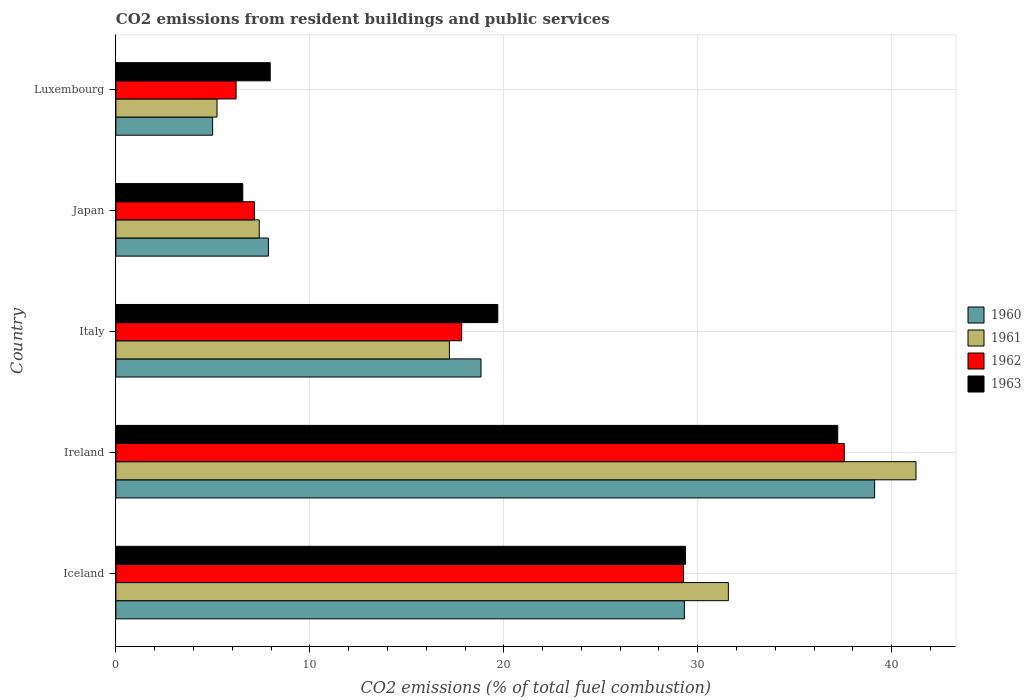How many groups of bars are there?
Offer a terse response. 5. Are the number of bars per tick equal to the number of legend labels?
Ensure brevity in your answer.  Yes. What is the label of the 3rd group of bars from the top?
Give a very brief answer. Italy. In how many cases, is the number of bars for a given country not equal to the number of legend labels?
Offer a very short reply. 0. What is the total CO2 emitted in 1960 in Iceland?
Your response must be concise. 29.31. Across all countries, what is the maximum total CO2 emitted in 1960?
Provide a short and direct response. 39.12. Across all countries, what is the minimum total CO2 emitted in 1963?
Make the answer very short. 6.54. In which country was the total CO2 emitted in 1963 maximum?
Provide a succinct answer. Ireland. In which country was the total CO2 emitted in 1961 minimum?
Give a very brief answer. Luxembourg. What is the total total CO2 emitted in 1960 in the graph?
Offer a very short reply. 100.11. What is the difference between the total CO2 emitted in 1963 in Iceland and that in Ireland?
Provide a short and direct response. -7.85. What is the difference between the total CO2 emitted in 1960 in Japan and the total CO2 emitted in 1962 in Italy?
Provide a succinct answer. -9.97. What is the average total CO2 emitted in 1960 per country?
Give a very brief answer. 20.02. What is the difference between the total CO2 emitted in 1960 and total CO2 emitted in 1961 in Ireland?
Provide a short and direct response. -2.13. In how many countries, is the total CO2 emitted in 1962 greater than 18 ?
Ensure brevity in your answer.  2. What is the ratio of the total CO2 emitted in 1961 in Ireland to that in Japan?
Your answer should be very brief. 5.58. Is the total CO2 emitted in 1963 in Iceland less than that in Luxembourg?
Your answer should be very brief. No. What is the difference between the highest and the second highest total CO2 emitted in 1962?
Your answer should be very brief. 8.29. What is the difference between the highest and the lowest total CO2 emitted in 1961?
Ensure brevity in your answer.  36.04. What does the 3rd bar from the top in Japan represents?
Ensure brevity in your answer.  1961. Is it the case that in every country, the sum of the total CO2 emitted in 1962 and total CO2 emitted in 1961 is greater than the total CO2 emitted in 1960?
Ensure brevity in your answer.  Yes. Are all the bars in the graph horizontal?
Provide a succinct answer. Yes. How many countries are there in the graph?
Offer a very short reply. 5. What is the difference between two consecutive major ticks on the X-axis?
Offer a terse response. 10. Does the graph contain any zero values?
Your response must be concise. No. Does the graph contain grids?
Your response must be concise. Yes. How many legend labels are there?
Offer a very short reply. 4. What is the title of the graph?
Your response must be concise. CO2 emissions from resident buildings and public services. Does "1973" appear as one of the legend labels in the graph?
Offer a very short reply. No. What is the label or title of the X-axis?
Give a very brief answer. CO2 emissions (% of total fuel combustion). What is the label or title of the Y-axis?
Give a very brief answer. Country. What is the CO2 emissions (% of total fuel combustion) of 1960 in Iceland?
Keep it short and to the point. 29.31. What is the CO2 emissions (% of total fuel combustion) in 1961 in Iceland?
Your answer should be compact. 31.58. What is the CO2 emissions (% of total fuel combustion) in 1962 in Iceland?
Your answer should be very brief. 29.27. What is the CO2 emissions (% of total fuel combustion) of 1963 in Iceland?
Ensure brevity in your answer.  29.37. What is the CO2 emissions (% of total fuel combustion) in 1960 in Ireland?
Ensure brevity in your answer.  39.12. What is the CO2 emissions (% of total fuel combustion) of 1961 in Ireland?
Your answer should be very brief. 41.25. What is the CO2 emissions (% of total fuel combustion) in 1962 in Ireland?
Make the answer very short. 37.55. What is the CO2 emissions (% of total fuel combustion) of 1963 in Ireland?
Provide a short and direct response. 37.22. What is the CO2 emissions (% of total fuel combustion) in 1960 in Italy?
Your answer should be very brief. 18.83. What is the CO2 emissions (% of total fuel combustion) in 1961 in Italy?
Provide a succinct answer. 17.2. What is the CO2 emissions (% of total fuel combustion) in 1962 in Italy?
Give a very brief answer. 17.83. What is the CO2 emissions (% of total fuel combustion) of 1963 in Italy?
Your answer should be very brief. 19.69. What is the CO2 emissions (% of total fuel combustion) of 1960 in Japan?
Give a very brief answer. 7.86. What is the CO2 emissions (% of total fuel combustion) of 1961 in Japan?
Make the answer very short. 7.39. What is the CO2 emissions (% of total fuel combustion) of 1962 in Japan?
Offer a terse response. 7.14. What is the CO2 emissions (% of total fuel combustion) of 1963 in Japan?
Give a very brief answer. 6.54. What is the CO2 emissions (% of total fuel combustion) of 1960 in Luxembourg?
Make the answer very short. 4.99. What is the CO2 emissions (% of total fuel combustion) of 1961 in Luxembourg?
Provide a succinct answer. 5.21. What is the CO2 emissions (% of total fuel combustion) of 1962 in Luxembourg?
Ensure brevity in your answer.  6.2. What is the CO2 emissions (% of total fuel combustion) of 1963 in Luxembourg?
Keep it short and to the point. 7.96. Across all countries, what is the maximum CO2 emissions (% of total fuel combustion) in 1960?
Provide a short and direct response. 39.12. Across all countries, what is the maximum CO2 emissions (% of total fuel combustion) in 1961?
Ensure brevity in your answer.  41.25. Across all countries, what is the maximum CO2 emissions (% of total fuel combustion) in 1962?
Give a very brief answer. 37.55. Across all countries, what is the maximum CO2 emissions (% of total fuel combustion) of 1963?
Give a very brief answer. 37.22. Across all countries, what is the minimum CO2 emissions (% of total fuel combustion) in 1960?
Your response must be concise. 4.99. Across all countries, what is the minimum CO2 emissions (% of total fuel combustion) of 1961?
Ensure brevity in your answer.  5.21. Across all countries, what is the minimum CO2 emissions (% of total fuel combustion) in 1962?
Your answer should be compact. 6.2. Across all countries, what is the minimum CO2 emissions (% of total fuel combustion) in 1963?
Ensure brevity in your answer.  6.54. What is the total CO2 emissions (% of total fuel combustion) of 1960 in the graph?
Offer a very short reply. 100.11. What is the total CO2 emissions (% of total fuel combustion) of 1961 in the graph?
Ensure brevity in your answer.  102.63. What is the total CO2 emissions (% of total fuel combustion) in 1962 in the graph?
Your answer should be very brief. 97.99. What is the total CO2 emissions (% of total fuel combustion) of 1963 in the graph?
Make the answer very short. 100.78. What is the difference between the CO2 emissions (% of total fuel combustion) in 1960 in Iceland and that in Ireland?
Your response must be concise. -9.81. What is the difference between the CO2 emissions (% of total fuel combustion) in 1961 in Iceland and that in Ireland?
Keep it short and to the point. -9.67. What is the difference between the CO2 emissions (% of total fuel combustion) of 1962 in Iceland and that in Ireland?
Your answer should be very brief. -8.29. What is the difference between the CO2 emissions (% of total fuel combustion) in 1963 in Iceland and that in Ireland?
Your answer should be compact. -7.85. What is the difference between the CO2 emissions (% of total fuel combustion) of 1960 in Iceland and that in Italy?
Offer a very short reply. 10.48. What is the difference between the CO2 emissions (% of total fuel combustion) in 1961 in Iceland and that in Italy?
Make the answer very short. 14.38. What is the difference between the CO2 emissions (% of total fuel combustion) in 1962 in Iceland and that in Italy?
Your response must be concise. 11.44. What is the difference between the CO2 emissions (% of total fuel combustion) of 1963 in Iceland and that in Italy?
Make the answer very short. 9.67. What is the difference between the CO2 emissions (% of total fuel combustion) of 1960 in Iceland and that in Japan?
Your answer should be very brief. 21.45. What is the difference between the CO2 emissions (% of total fuel combustion) of 1961 in Iceland and that in Japan?
Your answer should be compact. 24.19. What is the difference between the CO2 emissions (% of total fuel combustion) in 1962 in Iceland and that in Japan?
Offer a very short reply. 22.13. What is the difference between the CO2 emissions (% of total fuel combustion) of 1963 in Iceland and that in Japan?
Offer a terse response. 22.82. What is the difference between the CO2 emissions (% of total fuel combustion) in 1960 in Iceland and that in Luxembourg?
Ensure brevity in your answer.  24.32. What is the difference between the CO2 emissions (% of total fuel combustion) in 1961 in Iceland and that in Luxembourg?
Make the answer very short. 26.36. What is the difference between the CO2 emissions (% of total fuel combustion) in 1962 in Iceland and that in Luxembourg?
Offer a terse response. 23.07. What is the difference between the CO2 emissions (% of total fuel combustion) of 1963 in Iceland and that in Luxembourg?
Ensure brevity in your answer.  21.41. What is the difference between the CO2 emissions (% of total fuel combustion) of 1960 in Ireland and that in Italy?
Give a very brief answer. 20.29. What is the difference between the CO2 emissions (% of total fuel combustion) in 1961 in Ireland and that in Italy?
Give a very brief answer. 24.06. What is the difference between the CO2 emissions (% of total fuel combustion) of 1962 in Ireland and that in Italy?
Provide a short and direct response. 19.73. What is the difference between the CO2 emissions (% of total fuel combustion) in 1963 in Ireland and that in Italy?
Your answer should be compact. 17.53. What is the difference between the CO2 emissions (% of total fuel combustion) of 1960 in Ireland and that in Japan?
Ensure brevity in your answer.  31.26. What is the difference between the CO2 emissions (% of total fuel combustion) in 1961 in Ireland and that in Japan?
Keep it short and to the point. 33.86. What is the difference between the CO2 emissions (% of total fuel combustion) in 1962 in Ireland and that in Japan?
Your response must be concise. 30.41. What is the difference between the CO2 emissions (% of total fuel combustion) of 1963 in Ireland and that in Japan?
Keep it short and to the point. 30.68. What is the difference between the CO2 emissions (% of total fuel combustion) of 1960 in Ireland and that in Luxembourg?
Your answer should be very brief. 34.13. What is the difference between the CO2 emissions (% of total fuel combustion) in 1961 in Ireland and that in Luxembourg?
Your response must be concise. 36.04. What is the difference between the CO2 emissions (% of total fuel combustion) in 1962 in Ireland and that in Luxembourg?
Your answer should be very brief. 31.36. What is the difference between the CO2 emissions (% of total fuel combustion) of 1963 in Ireland and that in Luxembourg?
Your answer should be compact. 29.26. What is the difference between the CO2 emissions (% of total fuel combustion) of 1960 in Italy and that in Japan?
Keep it short and to the point. 10.96. What is the difference between the CO2 emissions (% of total fuel combustion) of 1961 in Italy and that in Japan?
Provide a short and direct response. 9.81. What is the difference between the CO2 emissions (% of total fuel combustion) of 1962 in Italy and that in Japan?
Your answer should be very brief. 10.69. What is the difference between the CO2 emissions (% of total fuel combustion) of 1963 in Italy and that in Japan?
Your answer should be compact. 13.15. What is the difference between the CO2 emissions (% of total fuel combustion) of 1960 in Italy and that in Luxembourg?
Ensure brevity in your answer.  13.84. What is the difference between the CO2 emissions (% of total fuel combustion) of 1961 in Italy and that in Luxembourg?
Offer a terse response. 11.98. What is the difference between the CO2 emissions (% of total fuel combustion) of 1962 in Italy and that in Luxembourg?
Keep it short and to the point. 11.63. What is the difference between the CO2 emissions (% of total fuel combustion) in 1963 in Italy and that in Luxembourg?
Offer a very short reply. 11.73. What is the difference between the CO2 emissions (% of total fuel combustion) of 1960 in Japan and that in Luxembourg?
Your answer should be compact. 2.87. What is the difference between the CO2 emissions (% of total fuel combustion) of 1961 in Japan and that in Luxembourg?
Keep it short and to the point. 2.18. What is the difference between the CO2 emissions (% of total fuel combustion) of 1962 in Japan and that in Luxembourg?
Provide a short and direct response. 0.94. What is the difference between the CO2 emissions (% of total fuel combustion) of 1963 in Japan and that in Luxembourg?
Provide a succinct answer. -1.41. What is the difference between the CO2 emissions (% of total fuel combustion) of 1960 in Iceland and the CO2 emissions (% of total fuel combustion) of 1961 in Ireland?
Ensure brevity in your answer.  -11.94. What is the difference between the CO2 emissions (% of total fuel combustion) in 1960 in Iceland and the CO2 emissions (% of total fuel combustion) in 1962 in Ireland?
Offer a very short reply. -8.24. What is the difference between the CO2 emissions (% of total fuel combustion) in 1960 in Iceland and the CO2 emissions (% of total fuel combustion) in 1963 in Ireland?
Your response must be concise. -7.91. What is the difference between the CO2 emissions (% of total fuel combustion) of 1961 in Iceland and the CO2 emissions (% of total fuel combustion) of 1962 in Ireland?
Offer a very short reply. -5.98. What is the difference between the CO2 emissions (% of total fuel combustion) of 1961 in Iceland and the CO2 emissions (% of total fuel combustion) of 1963 in Ireland?
Your answer should be compact. -5.64. What is the difference between the CO2 emissions (% of total fuel combustion) of 1962 in Iceland and the CO2 emissions (% of total fuel combustion) of 1963 in Ireland?
Provide a short and direct response. -7.95. What is the difference between the CO2 emissions (% of total fuel combustion) in 1960 in Iceland and the CO2 emissions (% of total fuel combustion) in 1961 in Italy?
Provide a short and direct response. 12.11. What is the difference between the CO2 emissions (% of total fuel combustion) in 1960 in Iceland and the CO2 emissions (% of total fuel combustion) in 1962 in Italy?
Offer a terse response. 11.48. What is the difference between the CO2 emissions (% of total fuel combustion) of 1960 in Iceland and the CO2 emissions (% of total fuel combustion) of 1963 in Italy?
Your answer should be very brief. 9.62. What is the difference between the CO2 emissions (% of total fuel combustion) in 1961 in Iceland and the CO2 emissions (% of total fuel combustion) in 1962 in Italy?
Offer a terse response. 13.75. What is the difference between the CO2 emissions (% of total fuel combustion) of 1961 in Iceland and the CO2 emissions (% of total fuel combustion) of 1963 in Italy?
Provide a short and direct response. 11.89. What is the difference between the CO2 emissions (% of total fuel combustion) of 1962 in Iceland and the CO2 emissions (% of total fuel combustion) of 1963 in Italy?
Provide a succinct answer. 9.58. What is the difference between the CO2 emissions (% of total fuel combustion) of 1960 in Iceland and the CO2 emissions (% of total fuel combustion) of 1961 in Japan?
Provide a succinct answer. 21.92. What is the difference between the CO2 emissions (% of total fuel combustion) of 1960 in Iceland and the CO2 emissions (% of total fuel combustion) of 1962 in Japan?
Provide a short and direct response. 22.17. What is the difference between the CO2 emissions (% of total fuel combustion) in 1960 in Iceland and the CO2 emissions (% of total fuel combustion) in 1963 in Japan?
Provide a short and direct response. 22.77. What is the difference between the CO2 emissions (% of total fuel combustion) in 1961 in Iceland and the CO2 emissions (% of total fuel combustion) in 1962 in Japan?
Your response must be concise. 24.44. What is the difference between the CO2 emissions (% of total fuel combustion) of 1961 in Iceland and the CO2 emissions (% of total fuel combustion) of 1963 in Japan?
Your answer should be compact. 25.04. What is the difference between the CO2 emissions (% of total fuel combustion) in 1962 in Iceland and the CO2 emissions (% of total fuel combustion) in 1963 in Japan?
Make the answer very short. 22.73. What is the difference between the CO2 emissions (% of total fuel combustion) in 1960 in Iceland and the CO2 emissions (% of total fuel combustion) in 1961 in Luxembourg?
Provide a succinct answer. 24.1. What is the difference between the CO2 emissions (% of total fuel combustion) in 1960 in Iceland and the CO2 emissions (% of total fuel combustion) in 1962 in Luxembourg?
Give a very brief answer. 23.11. What is the difference between the CO2 emissions (% of total fuel combustion) of 1960 in Iceland and the CO2 emissions (% of total fuel combustion) of 1963 in Luxembourg?
Ensure brevity in your answer.  21.35. What is the difference between the CO2 emissions (% of total fuel combustion) in 1961 in Iceland and the CO2 emissions (% of total fuel combustion) in 1962 in Luxembourg?
Give a very brief answer. 25.38. What is the difference between the CO2 emissions (% of total fuel combustion) of 1961 in Iceland and the CO2 emissions (% of total fuel combustion) of 1963 in Luxembourg?
Provide a short and direct response. 23.62. What is the difference between the CO2 emissions (% of total fuel combustion) of 1962 in Iceland and the CO2 emissions (% of total fuel combustion) of 1963 in Luxembourg?
Ensure brevity in your answer.  21.31. What is the difference between the CO2 emissions (% of total fuel combustion) in 1960 in Ireland and the CO2 emissions (% of total fuel combustion) in 1961 in Italy?
Offer a terse response. 21.92. What is the difference between the CO2 emissions (% of total fuel combustion) of 1960 in Ireland and the CO2 emissions (% of total fuel combustion) of 1962 in Italy?
Your answer should be compact. 21.29. What is the difference between the CO2 emissions (% of total fuel combustion) of 1960 in Ireland and the CO2 emissions (% of total fuel combustion) of 1963 in Italy?
Your answer should be very brief. 19.43. What is the difference between the CO2 emissions (% of total fuel combustion) of 1961 in Ireland and the CO2 emissions (% of total fuel combustion) of 1962 in Italy?
Your answer should be compact. 23.42. What is the difference between the CO2 emissions (% of total fuel combustion) of 1961 in Ireland and the CO2 emissions (% of total fuel combustion) of 1963 in Italy?
Your answer should be compact. 21.56. What is the difference between the CO2 emissions (% of total fuel combustion) in 1962 in Ireland and the CO2 emissions (% of total fuel combustion) in 1963 in Italy?
Your answer should be very brief. 17.86. What is the difference between the CO2 emissions (% of total fuel combustion) in 1960 in Ireland and the CO2 emissions (% of total fuel combustion) in 1961 in Japan?
Ensure brevity in your answer.  31.73. What is the difference between the CO2 emissions (% of total fuel combustion) of 1960 in Ireland and the CO2 emissions (% of total fuel combustion) of 1962 in Japan?
Your answer should be very brief. 31.98. What is the difference between the CO2 emissions (% of total fuel combustion) of 1960 in Ireland and the CO2 emissions (% of total fuel combustion) of 1963 in Japan?
Your response must be concise. 32.58. What is the difference between the CO2 emissions (% of total fuel combustion) in 1961 in Ireland and the CO2 emissions (% of total fuel combustion) in 1962 in Japan?
Your response must be concise. 34.11. What is the difference between the CO2 emissions (% of total fuel combustion) in 1961 in Ireland and the CO2 emissions (% of total fuel combustion) in 1963 in Japan?
Offer a very short reply. 34.71. What is the difference between the CO2 emissions (% of total fuel combustion) of 1962 in Ireland and the CO2 emissions (% of total fuel combustion) of 1963 in Japan?
Offer a terse response. 31.01. What is the difference between the CO2 emissions (% of total fuel combustion) of 1960 in Ireland and the CO2 emissions (% of total fuel combustion) of 1961 in Luxembourg?
Provide a succinct answer. 33.91. What is the difference between the CO2 emissions (% of total fuel combustion) of 1960 in Ireland and the CO2 emissions (% of total fuel combustion) of 1962 in Luxembourg?
Provide a short and direct response. 32.92. What is the difference between the CO2 emissions (% of total fuel combustion) in 1960 in Ireland and the CO2 emissions (% of total fuel combustion) in 1963 in Luxembourg?
Provide a succinct answer. 31.16. What is the difference between the CO2 emissions (% of total fuel combustion) in 1961 in Ireland and the CO2 emissions (% of total fuel combustion) in 1962 in Luxembourg?
Keep it short and to the point. 35.06. What is the difference between the CO2 emissions (% of total fuel combustion) in 1961 in Ireland and the CO2 emissions (% of total fuel combustion) in 1963 in Luxembourg?
Keep it short and to the point. 33.3. What is the difference between the CO2 emissions (% of total fuel combustion) of 1962 in Ireland and the CO2 emissions (% of total fuel combustion) of 1963 in Luxembourg?
Give a very brief answer. 29.6. What is the difference between the CO2 emissions (% of total fuel combustion) of 1960 in Italy and the CO2 emissions (% of total fuel combustion) of 1961 in Japan?
Ensure brevity in your answer.  11.43. What is the difference between the CO2 emissions (% of total fuel combustion) of 1960 in Italy and the CO2 emissions (% of total fuel combustion) of 1962 in Japan?
Your answer should be compact. 11.68. What is the difference between the CO2 emissions (% of total fuel combustion) of 1960 in Italy and the CO2 emissions (% of total fuel combustion) of 1963 in Japan?
Your answer should be compact. 12.28. What is the difference between the CO2 emissions (% of total fuel combustion) of 1961 in Italy and the CO2 emissions (% of total fuel combustion) of 1962 in Japan?
Make the answer very short. 10.05. What is the difference between the CO2 emissions (% of total fuel combustion) of 1961 in Italy and the CO2 emissions (% of total fuel combustion) of 1963 in Japan?
Provide a short and direct response. 10.65. What is the difference between the CO2 emissions (% of total fuel combustion) of 1962 in Italy and the CO2 emissions (% of total fuel combustion) of 1963 in Japan?
Your answer should be compact. 11.29. What is the difference between the CO2 emissions (% of total fuel combustion) of 1960 in Italy and the CO2 emissions (% of total fuel combustion) of 1961 in Luxembourg?
Offer a terse response. 13.61. What is the difference between the CO2 emissions (% of total fuel combustion) of 1960 in Italy and the CO2 emissions (% of total fuel combustion) of 1962 in Luxembourg?
Give a very brief answer. 12.63. What is the difference between the CO2 emissions (% of total fuel combustion) in 1960 in Italy and the CO2 emissions (% of total fuel combustion) in 1963 in Luxembourg?
Keep it short and to the point. 10.87. What is the difference between the CO2 emissions (% of total fuel combustion) of 1961 in Italy and the CO2 emissions (% of total fuel combustion) of 1962 in Luxembourg?
Provide a succinct answer. 11. What is the difference between the CO2 emissions (% of total fuel combustion) in 1961 in Italy and the CO2 emissions (% of total fuel combustion) in 1963 in Luxembourg?
Provide a succinct answer. 9.24. What is the difference between the CO2 emissions (% of total fuel combustion) of 1962 in Italy and the CO2 emissions (% of total fuel combustion) of 1963 in Luxembourg?
Your answer should be compact. 9.87. What is the difference between the CO2 emissions (% of total fuel combustion) in 1960 in Japan and the CO2 emissions (% of total fuel combustion) in 1961 in Luxembourg?
Offer a terse response. 2.65. What is the difference between the CO2 emissions (% of total fuel combustion) in 1960 in Japan and the CO2 emissions (% of total fuel combustion) in 1962 in Luxembourg?
Provide a succinct answer. 1.66. What is the difference between the CO2 emissions (% of total fuel combustion) of 1960 in Japan and the CO2 emissions (% of total fuel combustion) of 1963 in Luxembourg?
Make the answer very short. -0.09. What is the difference between the CO2 emissions (% of total fuel combustion) in 1961 in Japan and the CO2 emissions (% of total fuel combustion) in 1962 in Luxembourg?
Your answer should be very brief. 1.19. What is the difference between the CO2 emissions (% of total fuel combustion) of 1961 in Japan and the CO2 emissions (% of total fuel combustion) of 1963 in Luxembourg?
Offer a very short reply. -0.57. What is the difference between the CO2 emissions (% of total fuel combustion) in 1962 in Japan and the CO2 emissions (% of total fuel combustion) in 1963 in Luxembourg?
Offer a very short reply. -0.82. What is the average CO2 emissions (% of total fuel combustion) in 1960 per country?
Provide a short and direct response. 20.02. What is the average CO2 emissions (% of total fuel combustion) of 1961 per country?
Give a very brief answer. 20.53. What is the average CO2 emissions (% of total fuel combustion) in 1962 per country?
Keep it short and to the point. 19.6. What is the average CO2 emissions (% of total fuel combustion) of 1963 per country?
Give a very brief answer. 20.16. What is the difference between the CO2 emissions (% of total fuel combustion) in 1960 and CO2 emissions (% of total fuel combustion) in 1961 in Iceland?
Ensure brevity in your answer.  -2.27. What is the difference between the CO2 emissions (% of total fuel combustion) in 1960 and CO2 emissions (% of total fuel combustion) in 1962 in Iceland?
Provide a succinct answer. 0.04. What is the difference between the CO2 emissions (% of total fuel combustion) of 1960 and CO2 emissions (% of total fuel combustion) of 1963 in Iceland?
Your answer should be compact. -0.05. What is the difference between the CO2 emissions (% of total fuel combustion) of 1961 and CO2 emissions (% of total fuel combustion) of 1962 in Iceland?
Your answer should be very brief. 2.31. What is the difference between the CO2 emissions (% of total fuel combustion) of 1961 and CO2 emissions (% of total fuel combustion) of 1963 in Iceland?
Make the answer very short. 2.21. What is the difference between the CO2 emissions (% of total fuel combustion) in 1962 and CO2 emissions (% of total fuel combustion) in 1963 in Iceland?
Make the answer very short. -0.1. What is the difference between the CO2 emissions (% of total fuel combustion) of 1960 and CO2 emissions (% of total fuel combustion) of 1961 in Ireland?
Your response must be concise. -2.13. What is the difference between the CO2 emissions (% of total fuel combustion) of 1960 and CO2 emissions (% of total fuel combustion) of 1962 in Ireland?
Make the answer very short. 1.57. What is the difference between the CO2 emissions (% of total fuel combustion) in 1960 and CO2 emissions (% of total fuel combustion) in 1963 in Ireland?
Keep it short and to the point. 1.9. What is the difference between the CO2 emissions (% of total fuel combustion) in 1961 and CO2 emissions (% of total fuel combustion) in 1962 in Ireland?
Offer a terse response. 3.7. What is the difference between the CO2 emissions (% of total fuel combustion) in 1961 and CO2 emissions (% of total fuel combustion) in 1963 in Ireland?
Keep it short and to the point. 4.03. What is the difference between the CO2 emissions (% of total fuel combustion) of 1962 and CO2 emissions (% of total fuel combustion) of 1963 in Ireland?
Give a very brief answer. 0.34. What is the difference between the CO2 emissions (% of total fuel combustion) in 1960 and CO2 emissions (% of total fuel combustion) in 1961 in Italy?
Give a very brief answer. 1.63. What is the difference between the CO2 emissions (% of total fuel combustion) in 1960 and CO2 emissions (% of total fuel combustion) in 1963 in Italy?
Keep it short and to the point. -0.87. What is the difference between the CO2 emissions (% of total fuel combustion) of 1961 and CO2 emissions (% of total fuel combustion) of 1962 in Italy?
Ensure brevity in your answer.  -0.63. What is the difference between the CO2 emissions (% of total fuel combustion) of 1961 and CO2 emissions (% of total fuel combustion) of 1963 in Italy?
Offer a very short reply. -2.49. What is the difference between the CO2 emissions (% of total fuel combustion) in 1962 and CO2 emissions (% of total fuel combustion) in 1963 in Italy?
Provide a succinct answer. -1.86. What is the difference between the CO2 emissions (% of total fuel combustion) in 1960 and CO2 emissions (% of total fuel combustion) in 1961 in Japan?
Your response must be concise. 0.47. What is the difference between the CO2 emissions (% of total fuel combustion) of 1960 and CO2 emissions (% of total fuel combustion) of 1962 in Japan?
Your response must be concise. 0.72. What is the difference between the CO2 emissions (% of total fuel combustion) in 1960 and CO2 emissions (% of total fuel combustion) in 1963 in Japan?
Provide a succinct answer. 1.32. What is the difference between the CO2 emissions (% of total fuel combustion) in 1961 and CO2 emissions (% of total fuel combustion) in 1962 in Japan?
Ensure brevity in your answer.  0.25. What is the difference between the CO2 emissions (% of total fuel combustion) of 1961 and CO2 emissions (% of total fuel combustion) of 1963 in Japan?
Ensure brevity in your answer.  0.85. What is the difference between the CO2 emissions (% of total fuel combustion) in 1962 and CO2 emissions (% of total fuel combustion) in 1963 in Japan?
Provide a succinct answer. 0.6. What is the difference between the CO2 emissions (% of total fuel combustion) in 1960 and CO2 emissions (% of total fuel combustion) in 1961 in Luxembourg?
Your answer should be compact. -0.23. What is the difference between the CO2 emissions (% of total fuel combustion) in 1960 and CO2 emissions (% of total fuel combustion) in 1962 in Luxembourg?
Your answer should be very brief. -1.21. What is the difference between the CO2 emissions (% of total fuel combustion) of 1960 and CO2 emissions (% of total fuel combustion) of 1963 in Luxembourg?
Provide a short and direct response. -2.97. What is the difference between the CO2 emissions (% of total fuel combustion) in 1961 and CO2 emissions (% of total fuel combustion) in 1962 in Luxembourg?
Keep it short and to the point. -0.98. What is the difference between the CO2 emissions (% of total fuel combustion) in 1961 and CO2 emissions (% of total fuel combustion) in 1963 in Luxembourg?
Give a very brief answer. -2.74. What is the difference between the CO2 emissions (% of total fuel combustion) of 1962 and CO2 emissions (% of total fuel combustion) of 1963 in Luxembourg?
Offer a terse response. -1.76. What is the ratio of the CO2 emissions (% of total fuel combustion) of 1960 in Iceland to that in Ireland?
Offer a terse response. 0.75. What is the ratio of the CO2 emissions (% of total fuel combustion) of 1961 in Iceland to that in Ireland?
Your answer should be very brief. 0.77. What is the ratio of the CO2 emissions (% of total fuel combustion) of 1962 in Iceland to that in Ireland?
Keep it short and to the point. 0.78. What is the ratio of the CO2 emissions (% of total fuel combustion) of 1963 in Iceland to that in Ireland?
Provide a succinct answer. 0.79. What is the ratio of the CO2 emissions (% of total fuel combustion) in 1960 in Iceland to that in Italy?
Keep it short and to the point. 1.56. What is the ratio of the CO2 emissions (% of total fuel combustion) of 1961 in Iceland to that in Italy?
Offer a terse response. 1.84. What is the ratio of the CO2 emissions (% of total fuel combustion) in 1962 in Iceland to that in Italy?
Keep it short and to the point. 1.64. What is the ratio of the CO2 emissions (% of total fuel combustion) in 1963 in Iceland to that in Italy?
Your response must be concise. 1.49. What is the ratio of the CO2 emissions (% of total fuel combustion) of 1960 in Iceland to that in Japan?
Keep it short and to the point. 3.73. What is the ratio of the CO2 emissions (% of total fuel combustion) in 1961 in Iceland to that in Japan?
Your response must be concise. 4.27. What is the ratio of the CO2 emissions (% of total fuel combustion) of 1962 in Iceland to that in Japan?
Your response must be concise. 4.1. What is the ratio of the CO2 emissions (% of total fuel combustion) in 1963 in Iceland to that in Japan?
Keep it short and to the point. 4.49. What is the ratio of the CO2 emissions (% of total fuel combustion) in 1960 in Iceland to that in Luxembourg?
Give a very brief answer. 5.88. What is the ratio of the CO2 emissions (% of total fuel combustion) in 1961 in Iceland to that in Luxembourg?
Keep it short and to the point. 6.06. What is the ratio of the CO2 emissions (% of total fuel combustion) in 1962 in Iceland to that in Luxembourg?
Make the answer very short. 4.72. What is the ratio of the CO2 emissions (% of total fuel combustion) in 1963 in Iceland to that in Luxembourg?
Provide a succinct answer. 3.69. What is the ratio of the CO2 emissions (% of total fuel combustion) in 1960 in Ireland to that in Italy?
Make the answer very short. 2.08. What is the ratio of the CO2 emissions (% of total fuel combustion) in 1961 in Ireland to that in Italy?
Ensure brevity in your answer.  2.4. What is the ratio of the CO2 emissions (% of total fuel combustion) of 1962 in Ireland to that in Italy?
Provide a succinct answer. 2.11. What is the ratio of the CO2 emissions (% of total fuel combustion) in 1963 in Ireland to that in Italy?
Ensure brevity in your answer.  1.89. What is the ratio of the CO2 emissions (% of total fuel combustion) in 1960 in Ireland to that in Japan?
Your response must be concise. 4.98. What is the ratio of the CO2 emissions (% of total fuel combustion) of 1961 in Ireland to that in Japan?
Provide a short and direct response. 5.58. What is the ratio of the CO2 emissions (% of total fuel combustion) in 1962 in Ireland to that in Japan?
Make the answer very short. 5.26. What is the ratio of the CO2 emissions (% of total fuel combustion) in 1963 in Ireland to that in Japan?
Ensure brevity in your answer.  5.69. What is the ratio of the CO2 emissions (% of total fuel combustion) in 1960 in Ireland to that in Luxembourg?
Offer a very short reply. 7.84. What is the ratio of the CO2 emissions (% of total fuel combustion) of 1961 in Ireland to that in Luxembourg?
Keep it short and to the point. 7.91. What is the ratio of the CO2 emissions (% of total fuel combustion) of 1962 in Ireland to that in Luxembourg?
Ensure brevity in your answer.  6.06. What is the ratio of the CO2 emissions (% of total fuel combustion) of 1963 in Ireland to that in Luxembourg?
Make the answer very short. 4.68. What is the ratio of the CO2 emissions (% of total fuel combustion) of 1960 in Italy to that in Japan?
Ensure brevity in your answer.  2.39. What is the ratio of the CO2 emissions (% of total fuel combustion) in 1961 in Italy to that in Japan?
Your answer should be very brief. 2.33. What is the ratio of the CO2 emissions (% of total fuel combustion) in 1962 in Italy to that in Japan?
Offer a very short reply. 2.5. What is the ratio of the CO2 emissions (% of total fuel combustion) of 1963 in Italy to that in Japan?
Offer a very short reply. 3.01. What is the ratio of the CO2 emissions (% of total fuel combustion) in 1960 in Italy to that in Luxembourg?
Your response must be concise. 3.77. What is the ratio of the CO2 emissions (% of total fuel combustion) in 1961 in Italy to that in Luxembourg?
Give a very brief answer. 3.3. What is the ratio of the CO2 emissions (% of total fuel combustion) of 1962 in Italy to that in Luxembourg?
Your answer should be compact. 2.88. What is the ratio of the CO2 emissions (% of total fuel combustion) of 1963 in Italy to that in Luxembourg?
Offer a very short reply. 2.47. What is the ratio of the CO2 emissions (% of total fuel combustion) of 1960 in Japan to that in Luxembourg?
Provide a succinct answer. 1.58. What is the ratio of the CO2 emissions (% of total fuel combustion) in 1961 in Japan to that in Luxembourg?
Offer a very short reply. 1.42. What is the ratio of the CO2 emissions (% of total fuel combustion) of 1962 in Japan to that in Luxembourg?
Provide a succinct answer. 1.15. What is the ratio of the CO2 emissions (% of total fuel combustion) of 1963 in Japan to that in Luxembourg?
Your answer should be compact. 0.82. What is the difference between the highest and the second highest CO2 emissions (% of total fuel combustion) of 1960?
Your response must be concise. 9.81. What is the difference between the highest and the second highest CO2 emissions (% of total fuel combustion) of 1961?
Give a very brief answer. 9.67. What is the difference between the highest and the second highest CO2 emissions (% of total fuel combustion) in 1962?
Ensure brevity in your answer.  8.29. What is the difference between the highest and the second highest CO2 emissions (% of total fuel combustion) of 1963?
Give a very brief answer. 7.85. What is the difference between the highest and the lowest CO2 emissions (% of total fuel combustion) of 1960?
Ensure brevity in your answer.  34.13. What is the difference between the highest and the lowest CO2 emissions (% of total fuel combustion) in 1961?
Provide a short and direct response. 36.04. What is the difference between the highest and the lowest CO2 emissions (% of total fuel combustion) of 1962?
Give a very brief answer. 31.36. What is the difference between the highest and the lowest CO2 emissions (% of total fuel combustion) in 1963?
Offer a terse response. 30.68. 